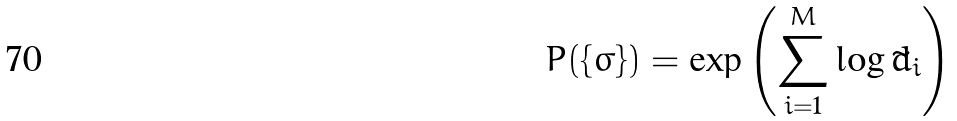Convert formula to latex. <formula><loc_0><loc_0><loc_500><loc_500>P ( \{ \sigma \} ) = \exp \left ( \sum ^ { M } _ { i = 1 } \log \tilde { d } _ { i } \right )</formula> 